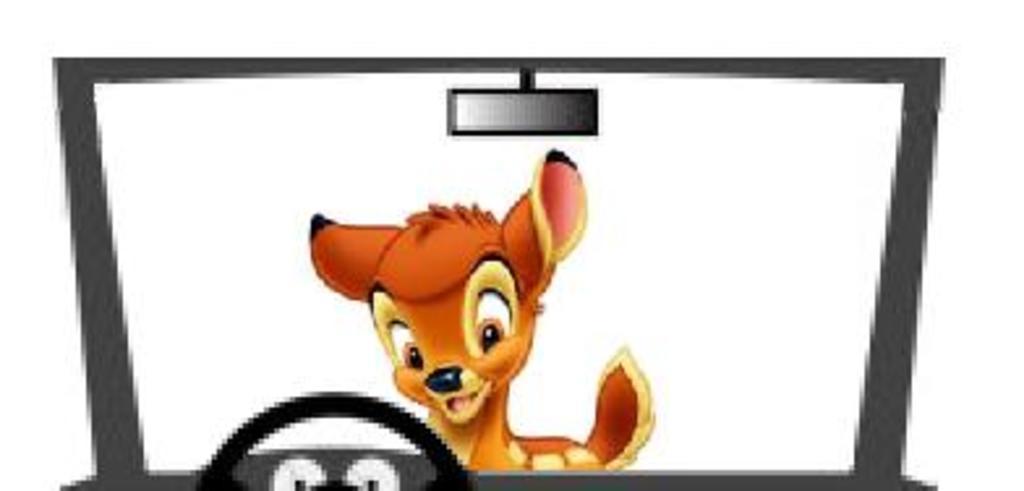In one or two sentences, can you explain what this image depicts? This is an animated picture, I can see a deer and a vehicle. 